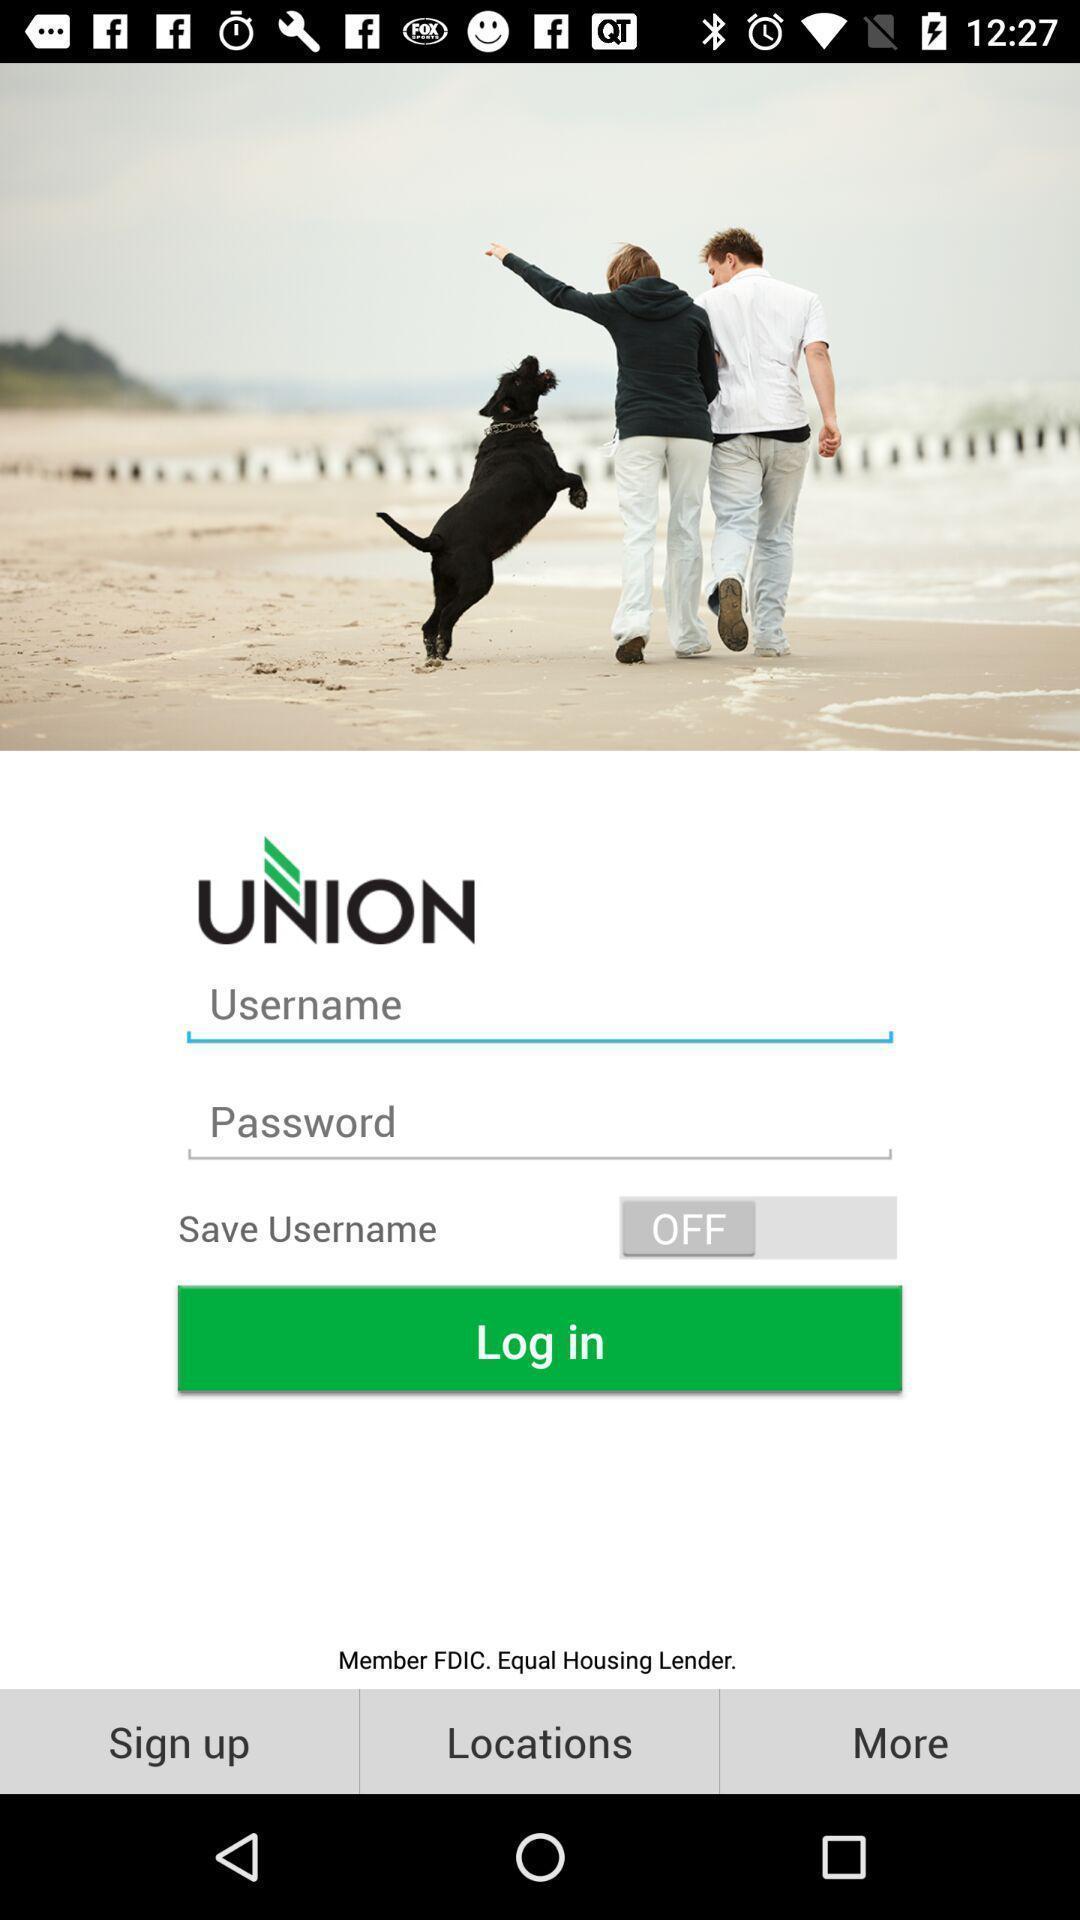Tell me what you see in this picture. Login page. 